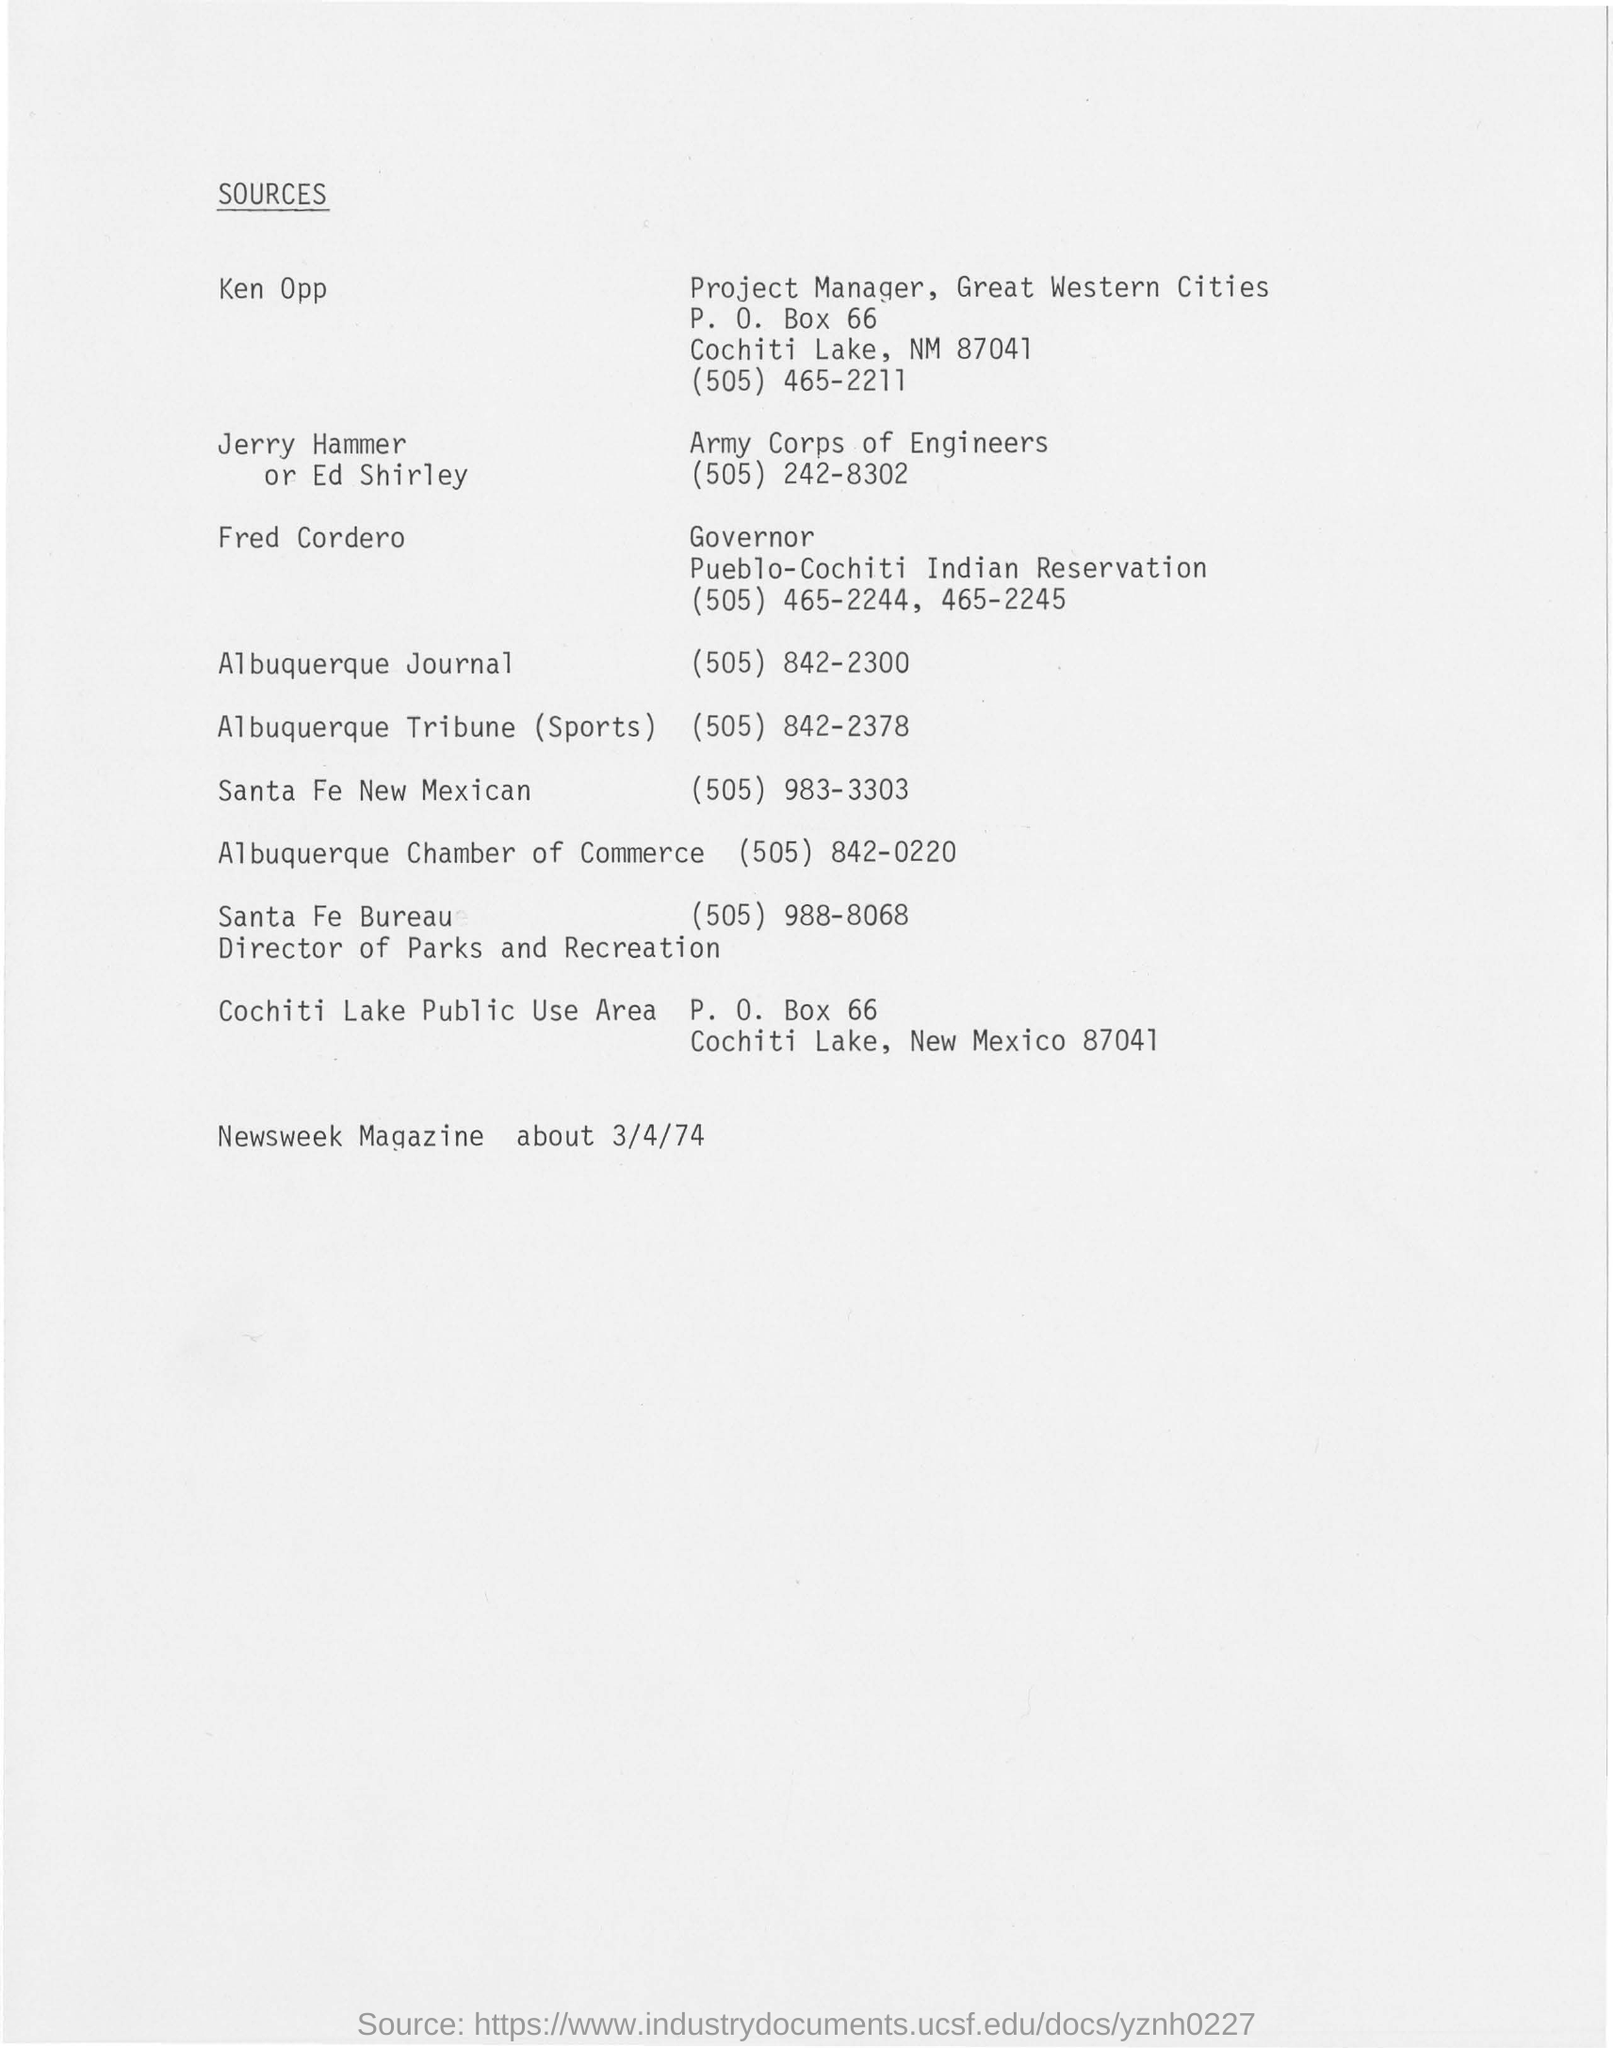Who is the governor of Pueblo-Cochiti Indian Reservation?
Provide a succinct answer. Fred Cordero. Who is the project manager of Great Western Citites?
Provide a short and direct response. Ken Opp. What is the contact no of Ken Opp?
Give a very brief answer. (505) 465-2211. 